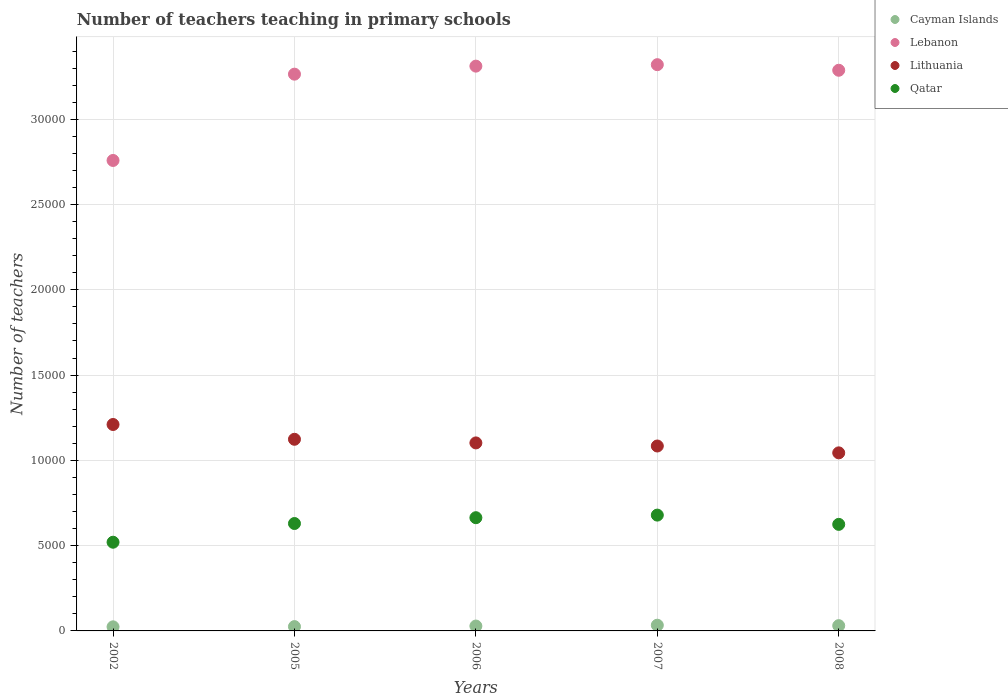Is the number of dotlines equal to the number of legend labels?
Give a very brief answer. Yes. What is the number of teachers teaching in primary schools in Lebanon in 2005?
Provide a short and direct response. 3.26e+04. Across all years, what is the maximum number of teachers teaching in primary schools in Qatar?
Your answer should be very brief. 6791. Across all years, what is the minimum number of teachers teaching in primary schools in Lebanon?
Make the answer very short. 2.76e+04. What is the total number of teachers teaching in primary schools in Qatar in the graph?
Your answer should be compact. 3.12e+04. What is the difference between the number of teachers teaching in primary schools in Lebanon in 2007 and that in 2008?
Keep it short and to the point. 327. What is the difference between the number of teachers teaching in primary schools in Lebanon in 2005 and the number of teachers teaching in primary schools in Qatar in 2007?
Make the answer very short. 2.59e+04. What is the average number of teachers teaching in primary schools in Qatar per year?
Keep it short and to the point. 6235.4. In the year 2005, what is the difference between the number of teachers teaching in primary schools in Lithuania and number of teachers teaching in primary schools in Lebanon?
Your answer should be very brief. -2.14e+04. What is the ratio of the number of teachers teaching in primary schools in Cayman Islands in 2007 to that in 2008?
Give a very brief answer. 1.08. Is the number of teachers teaching in primary schools in Lithuania in 2007 less than that in 2008?
Offer a terse response. No. What is the difference between the highest and the lowest number of teachers teaching in primary schools in Lithuania?
Your response must be concise. 1663. Is the sum of the number of teachers teaching in primary schools in Lithuania in 2006 and 2008 greater than the maximum number of teachers teaching in primary schools in Qatar across all years?
Make the answer very short. Yes. Is it the case that in every year, the sum of the number of teachers teaching in primary schools in Lebanon and number of teachers teaching in primary schools in Qatar  is greater than the number of teachers teaching in primary schools in Cayman Islands?
Ensure brevity in your answer.  Yes. How many dotlines are there?
Keep it short and to the point. 4. How many years are there in the graph?
Provide a succinct answer. 5. What is the difference between two consecutive major ticks on the Y-axis?
Offer a terse response. 5000. Does the graph contain any zero values?
Your answer should be very brief. No. Does the graph contain grids?
Give a very brief answer. Yes. Where does the legend appear in the graph?
Keep it short and to the point. Top right. What is the title of the graph?
Offer a terse response. Number of teachers teaching in primary schools. What is the label or title of the Y-axis?
Keep it short and to the point. Number of teachers. What is the Number of teachers in Cayman Islands in 2002?
Offer a terse response. 240. What is the Number of teachers in Lebanon in 2002?
Provide a short and direct response. 2.76e+04. What is the Number of teachers in Lithuania in 2002?
Your answer should be very brief. 1.21e+04. What is the Number of teachers in Qatar in 2002?
Ensure brevity in your answer.  5201. What is the Number of teachers in Cayman Islands in 2005?
Give a very brief answer. 253. What is the Number of teachers of Lebanon in 2005?
Make the answer very short. 3.26e+04. What is the Number of teachers in Lithuania in 2005?
Give a very brief answer. 1.12e+04. What is the Number of teachers of Qatar in 2005?
Provide a short and direct response. 6298. What is the Number of teachers in Cayman Islands in 2006?
Your answer should be very brief. 286. What is the Number of teachers in Lebanon in 2006?
Keep it short and to the point. 3.31e+04. What is the Number of teachers in Lithuania in 2006?
Offer a very short reply. 1.10e+04. What is the Number of teachers of Qatar in 2006?
Offer a terse response. 6639. What is the Number of teachers in Cayman Islands in 2007?
Ensure brevity in your answer.  335. What is the Number of teachers in Lebanon in 2007?
Your response must be concise. 3.32e+04. What is the Number of teachers of Lithuania in 2007?
Keep it short and to the point. 1.08e+04. What is the Number of teachers in Qatar in 2007?
Provide a succinct answer. 6791. What is the Number of teachers of Cayman Islands in 2008?
Give a very brief answer. 309. What is the Number of teachers in Lebanon in 2008?
Provide a short and direct response. 3.29e+04. What is the Number of teachers in Lithuania in 2008?
Make the answer very short. 1.04e+04. What is the Number of teachers of Qatar in 2008?
Provide a short and direct response. 6248. Across all years, what is the maximum Number of teachers of Cayman Islands?
Your answer should be compact. 335. Across all years, what is the maximum Number of teachers in Lebanon?
Make the answer very short. 3.32e+04. Across all years, what is the maximum Number of teachers in Lithuania?
Your response must be concise. 1.21e+04. Across all years, what is the maximum Number of teachers in Qatar?
Ensure brevity in your answer.  6791. Across all years, what is the minimum Number of teachers of Cayman Islands?
Give a very brief answer. 240. Across all years, what is the minimum Number of teachers of Lebanon?
Offer a terse response. 2.76e+04. Across all years, what is the minimum Number of teachers in Lithuania?
Offer a very short reply. 1.04e+04. Across all years, what is the minimum Number of teachers of Qatar?
Provide a succinct answer. 5201. What is the total Number of teachers of Cayman Islands in the graph?
Provide a succinct answer. 1423. What is the total Number of teachers in Lebanon in the graph?
Ensure brevity in your answer.  1.59e+05. What is the total Number of teachers in Lithuania in the graph?
Offer a very short reply. 5.56e+04. What is the total Number of teachers of Qatar in the graph?
Offer a terse response. 3.12e+04. What is the difference between the Number of teachers of Cayman Islands in 2002 and that in 2005?
Offer a terse response. -13. What is the difference between the Number of teachers in Lebanon in 2002 and that in 2005?
Offer a terse response. -5060. What is the difference between the Number of teachers of Lithuania in 2002 and that in 2005?
Make the answer very short. 867. What is the difference between the Number of teachers in Qatar in 2002 and that in 2005?
Offer a terse response. -1097. What is the difference between the Number of teachers of Cayman Islands in 2002 and that in 2006?
Make the answer very short. -46. What is the difference between the Number of teachers in Lebanon in 2002 and that in 2006?
Offer a very short reply. -5531. What is the difference between the Number of teachers in Lithuania in 2002 and that in 2006?
Keep it short and to the point. 1080. What is the difference between the Number of teachers of Qatar in 2002 and that in 2006?
Provide a short and direct response. -1438. What is the difference between the Number of teachers in Cayman Islands in 2002 and that in 2007?
Your answer should be compact. -95. What is the difference between the Number of teachers of Lebanon in 2002 and that in 2007?
Your answer should be very brief. -5616. What is the difference between the Number of teachers of Lithuania in 2002 and that in 2007?
Your response must be concise. 1261. What is the difference between the Number of teachers in Qatar in 2002 and that in 2007?
Keep it short and to the point. -1590. What is the difference between the Number of teachers of Cayman Islands in 2002 and that in 2008?
Keep it short and to the point. -69. What is the difference between the Number of teachers in Lebanon in 2002 and that in 2008?
Keep it short and to the point. -5289. What is the difference between the Number of teachers of Lithuania in 2002 and that in 2008?
Ensure brevity in your answer.  1663. What is the difference between the Number of teachers in Qatar in 2002 and that in 2008?
Keep it short and to the point. -1047. What is the difference between the Number of teachers in Cayman Islands in 2005 and that in 2006?
Make the answer very short. -33. What is the difference between the Number of teachers in Lebanon in 2005 and that in 2006?
Provide a short and direct response. -471. What is the difference between the Number of teachers in Lithuania in 2005 and that in 2006?
Give a very brief answer. 213. What is the difference between the Number of teachers of Qatar in 2005 and that in 2006?
Keep it short and to the point. -341. What is the difference between the Number of teachers of Cayman Islands in 2005 and that in 2007?
Your answer should be compact. -82. What is the difference between the Number of teachers of Lebanon in 2005 and that in 2007?
Offer a very short reply. -556. What is the difference between the Number of teachers of Lithuania in 2005 and that in 2007?
Provide a succinct answer. 394. What is the difference between the Number of teachers of Qatar in 2005 and that in 2007?
Your answer should be compact. -493. What is the difference between the Number of teachers of Cayman Islands in 2005 and that in 2008?
Offer a terse response. -56. What is the difference between the Number of teachers in Lebanon in 2005 and that in 2008?
Provide a short and direct response. -229. What is the difference between the Number of teachers in Lithuania in 2005 and that in 2008?
Ensure brevity in your answer.  796. What is the difference between the Number of teachers in Cayman Islands in 2006 and that in 2007?
Give a very brief answer. -49. What is the difference between the Number of teachers of Lebanon in 2006 and that in 2007?
Your answer should be very brief. -85. What is the difference between the Number of teachers of Lithuania in 2006 and that in 2007?
Provide a succinct answer. 181. What is the difference between the Number of teachers of Qatar in 2006 and that in 2007?
Provide a succinct answer. -152. What is the difference between the Number of teachers of Cayman Islands in 2006 and that in 2008?
Your answer should be compact. -23. What is the difference between the Number of teachers of Lebanon in 2006 and that in 2008?
Offer a terse response. 242. What is the difference between the Number of teachers of Lithuania in 2006 and that in 2008?
Offer a terse response. 583. What is the difference between the Number of teachers of Qatar in 2006 and that in 2008?
Your answer should be compact. 391. What is the difference between the Number of teachers in Lebanon in 2007 and that in 2008?
Ensure brevity in your answer.  327. What is the difference between the Number of teachers in Lithuania in 2007 and that in 2008?
Keep it short and to the point. 402. What is the difference between the Number of teachers in Qatar in 2007 and that in 2008?
Provide a succinct answer. 543. What is the difference between the Number of teachers in Cayman Islands in 2002 and the Number of teachers in Lebanon in 2005?
Your response must be concise. -3.24e+04. What is the difference between the Number of teachers of Cayman Islands in 2002 and the Number of teachers of Lithuania in 2005?
Keep it short and to the point. -1.10e+04. What is the difference between the Number of teachers of Cayman Islands in 2002 and the Number of teachers of Qatar in 2005?
Provide a short and direct response. -6058. What is the difference between the Number of teachers in Lebanon in 2002 and the Number of teachers in Lithuania in 2005?
Offer a very short reply. 1.63e+04. What is the difference between the Number of teachers of Lebanon in 2002 and the Number of teachers of Qatar in 2005?
Provide a short and direct response. 2.13e+04. What is the difference between the Number of teachers of Lithuania in 2002 and the Number of teachers of Qatar in 2005?
Offer a very short reply. 5806. What is the difference between the Number of teachers in Cayman Islands in 2002 and the Number of teachers in Lebanon in 2006?
Make the answer very short. -3.29e+04. What is the difference between the Number of teachers in Cayman Islands in 2002 and the Number of teachers in Lithuania in 2006?
Your answer should be compact. -1.08e+04. What is the difference between the Number of teachers of Cayman Islands in 2002 and the Number of teachers of Qatar in 2006?
Offer a terse response. -6399. What is the difference between the Number of teachers of Lebanon in 2002 and the Number of teachers of Lithuania in 2006?
Your response must be concise. 1.66e+04. What is the difference between the Number of teachers of Lebanon in 2002 and the Number of teachers of Qatar in 2006?
Keep it short and to the point. 2.09e+04. What is the difference between the Number of teachers in Lithuania in 2002 and the Number of teachers in Qatar in 2006?
Offer a terse response. 5465. What is the difference between the Number of teachers of Cayman Islands in 2002 and the Number of teachers of Lebanon in 2007?
Your answer should be very brief. -3.30e+04. What is the difference between the Number of teachers in Cayman Islands in 2002 and the Number of teachers in Lithuania in 2007?
Your answer should be compact. -1.06e+04. What is the difference between the Number of teachers of Cayman Islands in 2002 and the Number of teachers of Qatar in 2007?
Provide a succinct answer. -6551. What is the difference between the Number of teachers of Lebanon in 2002 and the Number of teachers of Lithuania in 2007?
Your answer should be very brief. 1.67e+04. What is the difference between the Number of teachers of Lebanon in 2002 and the Number of teachers of Qatar in 2007?
Your answer should be compact. 2.08e+04. What is the difference between the Number of teachers of Lithuania in 2002 and the Number of teachers of Qatar in 2007?
Your response must be concise. 5313. What is the difference between the Number of teachers in Cayman Islands in 2002 and the Number of teachers in Lebanon in 2008?
Make the answer very short. -3.26e+04. What is the difference between the Number of teachers of Cayman Islands in 2002 and the Number of teachers of Lithuania in 2008?
Offer a terse response. -1.02e+04. What is the difference between the Number of teachers of Cayman Islands in 2002 and the Number of teachers of Qatar in 2008?
Offer a very short reply. -6008. What is the difference between the Number of teachers in Lebanon in 2002 and the Number of teachers in Lithuania in 2008?
Your answer should be compact. 1.71e+04. What is the difference between the Number of teachers of Lebanon in 2002 and the Number of teachers of Qatar in 2008?
Make the answer very short. 2.13e+04. What is the difference between the Number of teachers in Lithuania in 2002 and the Number of teachers in Qatar in 2008?
Offer a very short reply. 5856. What is the difference between the Number of teachers of Cayman Islands in 2005 and the Number of teachers of Lebanon in 2006?
Your answer should be compact. -3.29e+04. What is the difference between the Number of teachers in Cayman Islands in 2005 and the Number of teachers in Lithuania in 2006?
Make the answer very short. -1.08e+04. What is the difference between the Number of teachers in Cayman Islands in 2005 and the Number of teachers in Qatar in 2006?
Your answer should be very brief. -6386. What is the difference between the Number of teachers of Lebanon in 2005 and the Number of teachers of Lithuania in 2006?
Make the answer very short. 2.16e+04. What is the difference between the Number of teachers in Lebanon in 2005 and the Number of teachers in Qatar in 2006?
Your response must be concise. 2.60e+04. What is the difference between the Number of teachers of Lithuania in 2005 and the Number of teachers of Qatar in 2006?
Ensure brevity in your answer.  4598. What is the difference between the Number of teachers in Cayman Islands in 2005 and the Number of teachers in Lebanon in 2007?
Offer a very short reply. -3.29e+04. What is the difference between the Number of teachers in Cayman Islands in 2005 and the Number of teachers in Lithuania in 2007?
Give a very brief answer. -1.06e+04. What is the difference between the Number of teachers in Cayman Islands in 2005 and the Number of teachers in Qatar in 2007?
Your answer should be very brief. -6538. What is the difference between the Number of teachers of Lebanon in 2005 and the Number of teachers of Lithuania in 2007?
Give a very brief answer. 2.18e+04. What is the difference between the Number of teachers in Lebanon in 2005 and the Number of teachers in Qatar in 2007?
Provide a succinct answer. 2.59e+04. What is the difference between the Number of teachers of Lithuania in 2005 and the Number of teachers of Qatar in 2007?
Make the answer very short. 4446. What is the difference between the Number of teachers of Cayman Islands in 2005 and the Number of teachers of Lebanon in 2008?
Keep it short and to the point. -3.26e+04. What is the difference between the Number of teachers of Cayman Islands in 2005 and the Number of teachers of Lithuania in 2008?
Give a very brief answer. -1.02e+04. What is the difference between the Number of teachers in Cayman Islands in 2005 and the Number of teachers in Qatar in 2008?
Your answer should be very brief. -5995. What is the difference between the Number of teachers in Lebanon in 2005 and the Number of teachers in Lithuania in 2008?
Provide a succinct answer. 2.22e+04. What is the difference between the Number of teachers in Lebanon in 2005 and the Number of teachers in Qatar in 2008?
Offer a terse response. 2.64e+04. What is the difference between the Number of teachers in Lithuania in 2005 and the Number of teachers in Qatar in 2008?
Make the answer very short. 4989. What is the difference between the Number of teachers in Cayman Islands in 2006 and the Number of teachers in Lebanon in 2007?
Make the answer very short. -3.29e+04. What is the difference between the Number of teachers in Cayman Islands in 2006 and the Number of teachers in Lithuania in 2007?
Your answer should be compact. -1.06e+04. What is the difference between the Number of teachers in Cayman Islands in 2006 and the Number of teachers in Qatar in 2007?
Provide a succinct answer. -6505. What is the difference between the Number of teachers in Lebanon in 2006 and the Number of teachers in Lithuania in 2007?
Offer a very short reply. 2.23e+04. What is the difference between the Number of teachers of Lebanon in 2006 and the Number of teachers of Qatar in 2007?
Offer a very short reply. 2.63e+04. What is the difference between the Number of teachers of Lithuania in 2006 and the Number of teachers of Qatar in 2007?
Offer a very short reply. 4233. What is the difference between the Number of teachers of Cayman Islands in 2006 and the Number of teachers of Lebanon in 2008?
Provide a short and direct response. -3.26e+04. What is the difference between the Number of teachers of Cayman Islands in 2006 and the Number of teachers of Lithuania in 2008?
Provide a short and direct response. -1.02e+04. What is the difference between the Number of teachers of Cayman Islands in 2006 and the Number of teachers of Qatar in 2008?
Your response must be concise. -5962. What is the difference between the Number of teachers of Lebanon in 2006 and the Number of teachers of Lithuania in 2008?
Provide a succinct answer. 2.27e+04. What is the difference between the Number of teachers of Lebanon in 2006 and the Number of teachers of Qatar in 2008?
Offer a terse response. 2.69e+04. What is the difference between the Number of teachers in Lithuania in 2006 and the Number of teachers in Qatar in 2008?
Make the answer very short. 4776. What is the difference between the Number of teachers in Cayman Islands in 2007 and the Number of teachers in Lebanon in 2008?
Your answer should be very brief. -3.25e+04. What is the difference between the Number of teachers of Cayman Islands in 2007 and the Number of teachers of Lithuania in 2008?
Your answer should be compact. -1.01e+04. What is the difference between the Number of teachers of Cayman Islands in 2007 and the Number of teachers of Qatar in 2008?
Ensure brevity in your answer.  -5913. What is the difference between the Number of teachers of Lebanon in 2007 and the Number of teachers of Lithuania in 2008?
Offer a very short reply. 2.28e+04. What is the difference between the Number of teachers of Lebanon in 2007 and the Number of teachers of Qatar in 2008?
Keep it short and to the point. 2.70e+04. What is the difference between the Number of teachers of Lithuania in 2007 and the Number of teachers of Qatar in 2008?
Provide a succinct answer. 4595. What is the average Number of teachers in Cayman Islands per year?
Your response must be concise. 284.6. What is the average Number of teachers of Lebanon per year?
Make the answer very short. 3.19e+04. What is the average Number of teachers of Lithuania per year?
Your answer should be compact. 1.11e+04. What is the average Number of teachers in Qatar per year?
Keep it short and to the point. 6235.4. In the year 2002, what is the difference between the Number of teachers of Cayman Islands and Number of teachers of Lebanon?
Ensure brevity in your answer.  -2.73e+04. In the year 2002, what is the difference between the Number of teachers of Cayman Islands and Number of teachers of Lithuania?
Provide a short and direct response. -1.19e+04. In the year 2002, what is the difference between the Number of teachers in Cayman Islands and Number of teachers in Qatar?
Give a very brief answer. -4961. In the year 2002, what is the difference between the Number of teachers of Lebanon and Number of teachers of Lithuania?
Provide a succinct answer. 1.55e+04. In the year 2002, what is the difference between the Number of teachers of Lebanon and Number of teachers of Qatar?
Your answer should be compact. 2.24e+04. In the year 2002, what is the difference between the Number of teachers of Lithuania and Number of teachers of Qatar?
Keep it short and to the point. 6903. In the year 2005, what is the difference between the Number of teachers in Cayman Islands and Number of teachers in Lebanon?
Your answer should be compact. -3.24e+04. In the year 2005, what is the difference between the Number of teachers in Cayman Islands and Number of teachers in Lithuania?
Offer a very short reply. -1.10e+04. In the year 2005, what is the difference between the Number of teachers in Cayman Islands and Number of teachers in Qatar?
Make the answer very short. -6045. In the year 2005, what is the difference between the Number of teachers of Lebanon and Number of teachers of Lithuania?
Your response must be concise. 2.14e+04. In the year 2005, what is the difference between the Number of teachers of Lebanon and Number of teachers of Qatar?
Offer a very short reply. 2.63e+04. In the year 2005, what is the difference between the Number of teachers of Lithuania and Number of teachers of Qatar?
Offer a very short reply. 4939. In the year 2006, what is the difference between the Number of teachers of Cayman Islands and Number of teachers of Lebanon?
Provide a succinct answer. -3.28e+04. In the year 2006, what is the difference between the Number of teachers of Cayman Islands and Number of teachers of Lithuania?
Your response must be concise. -1.07e+04. In the year 2006, what is the difference between the Number of teachers of Cayman Islands and Number of teachers of Qatar?
Make the answer very short. -6353. In the year 2006, what is the difference between the Number of teachers of Lebanon and Number of teachers of Lithuania?
Offer a terse response. 2.21e+04. In the year 2006, what is the difference between the Number of teachers of Lebanon and Number of teachers of Qatar?
Make the answer very short. 2.65e+04. In the year 2006, what is the difference between the Number of teachers of Lithuania and Number of teachers of Qatar?
Provide a succinct answer. 4385. In the year 2007, what is the difference between the Number of teachers in Cayman Islands and Number of teachers in Lebanon?
Your response must be concise. -3.29e+04. In the year 2007, what is the difference between the Number of teachers of Cayman Islands and Number of teachers of Lithuania?
Make the answer very short. -1.05e+04. In the year 2007, what is the difference between the Number of teachers of Cayman Islands and Number of teachers of Qatar?
Give a very brief answer. -6456. In the year 2007, what is the difference between the Number of teachers of Lebanon and Number of teachers of Lithuania?
Offer a terse response. 2.24e+04. In the year 2007, what is the difference between the Number of teachers in Lebanon and Number of teachers in Qatar?
Offer a terse response. 2.64e+04. In the year 2007, what is the difference between the Number of teachers of Lithuania and Number of teachers of Qatar?
Offer a very short reply. 4052. In the year 2008, what is the difference between the Number of teachers of Cayman Islands and Number of teachers of Lebanon?
Your response must be concise. -3.26e+04. In the year 2008, what is the difference between the Number of teachers of Cayman Islands and Number of teachers of Lithuania?
Make the answer very short. -1.01e+04. In the year 2008, what is the difference between the Number of teachers of Cayman Islands and Number of teachers of Qatar?
Offer a terse response. -5939. In the year 2008, what is the difference between the Number of teachers of Lebanon and Number of teachers of Lithuania?
Make the answer very short. 2.24e+04. In the year 2008, what is the difference between the Number of teachers in Lebanon and Number of teachers in Qatar?
Your answer should be very brief. 2.66e+04. In the year 2008, what is the difference between the Number of teachers in Lithuania and Number of teachers in Qatar?
Offer a very short reply. 4193. What is the ratio of the Number of teachers of Cayman Islands in 2002 to that in 2005?
Your answer should be compact. 0.95. What is the ratio of the Number of teachers of Lebanon in 2002 to that in 2005?
Provide a short and direct response. 0.84. What is the ratio of the Number of teachers of Lithuania in 2002 to that in 2005?
Offer a very short reply. 1.08. What is the ratio of the Number of teachers of Qatar in 2002 to that in 2005?
Make the answer very short. 0.83. What is the ratio of the Number of teachers in Cayman Islands in 2002 to that in 2006?
Give a very brief answer. 0.84. What is the ratio of the Number of teachers in Lebanon in 2002 to that in 2006?
Your answer should be very brief. 0.83. What is the ratio of the Number of teachers of Lithuania in 2002 to that in 2006?
Offer a very short reply. 1.1. What is the ratio of the Number of teachers of Qatar in 2002 to that in 2006?
Give a very brief answer. 0.78. What is the ratio of the Number of teachers in Cayman Islands in 2002 to that in 2007?
Offer a terse response. 0.72. What is the ratio of the Number of teachers of Lebanon in 2002 to that in 2007?
Your response must be concise. 0.83. What is the ratio of the Number of teachers of Lithuania in 2002 to that in 2007?
Offer a very short reply. 1.12. What is the ratio of the Number of teachers in Qatar in 2002 to that in 2007?
Give a very brief answer. 0.77. What is the ratio of the Number of teachers of Cayman Islands in 2002 to that in 2008?
Your answer should be very brief. 0.78. What is the ratio of the Number of teachers in Lebanon in 2002 to that in 2008?
Offer a very short reply. 0.84. What is the ratio of the Number of teachers of Lithuania in 2002 to that in 2008?
Your answer should be very brief. 1.16. What is the ratio of the Number of teachers of Qatar in 2002 to that in 2008?
Make the answer very short. 0.83. What is the ratio of the Number of teachers in Cayman Islands in 2005 to that in 2006?
Ensure brevity in your answer.  0.88. What is the ratio of the Number of teachers in Lebanon in 2005 to that in 2006?
Your response must be concise. 0.99. What is the ratio of the Number of teachers in Lithuania in 2005 to that in 2006?
Provide a succinct answer. 1.02. What is the ratio of the Number of teachers in Qatar in 2005 to that in 2006?
Your answer should be compact. 0.95. What is the ratio of the Number of teachers in Cayman Islands in 2005 to that in 2007?
Offer a terse response. 0.76. What is the ratio of the Number of teachers in Lebanon in 2005 to that in 2007?
Give a very brief answer. 0.98. What is the ratio of the Number of teachers in Lithuania in 2005 to that in 2007?
Offer a very short reply. 1.04. What is the ratio of the Number of teachers in Qatar in 2005 to that in 2007?
Provide a succinct answer. 0.93. What is the ratio of the Number of teachers of Cayman Islands in 2005 to that in 2008?
Provide a short and direct response. 0.82. What is the ratio of the Number of teachers in Lebanon in 2005 to that in 2008?
Give a very brief answer. 0.99. What is the ratio of the Number of teachers in Lithuania in 2005 to that in 2008?
Your answer should be very brief. 1.08. What is the ratio of the Number of teachers in Qatar in 2005 to that in 2008?
Offer a terse response. 1.01. What is the ratio of the Number of teachers of Cayman Islands in 2006 to that in 2007?
Make the answer very short. 0.85. What is the ratio of the Number of teachers of Lebanon in 2006 to that in 2007?
Your answer should be compact. 1. What is the ratio of the Number of teachers of Lithuania in 2006 to that in 2007?
Provide a short and direct response. 1.02. What is the ratio of the Number of teachers of Qatar in 2006 to that in 2007?
Keep it short and to the point. 0.98. What is the ratio of the Number of teachers in Cayman Islands in 2006 to that in 2008?
Your answer should be very brief. 0.93. What is the ratio of the Number of teachers of Lebanon in 2006 to that in 2008?
Offer a terse response. 1.01. What is the ratio of the Number of teachers in Lithuania in 2006 to that in 2008?
Offer a terse response. 1.06. What is the ratio of the Number of teachers of Qatar in 2006 to that in 2008?
Offer a terse response. 1.06. What is the ratio of the Number of teachers in Cayman Islands in 2007 to that in 2008?
Ensure brevity in your answer.  1.08. What is the ratio of the Number of teachers in Lebanon in 2007 to that in 2008?
Your response must be concise. 1.01. What is the ratio of the Number of teachers in Lithuania in 2007 to that in 2008?
Your answer should be compact. 1.04. What is the ratio of the Number of teachers of Qatar in 2007 to that in 2008?
Provide a succinct answer. 1.09. What is the difference between the highest and the second highest Number of teachers in Lithuania?
Give a very brief answer. 867. What is the difference between the highest and the second highest Number of teachers in Qatar?
Offer a terse response. 152. What is the difference between the highest and the lowest Number of teachers of Lebanon?
Provide a succinct answer. 5616. What is the difference between the highest and the lowest Number of teachers of Lithuania?
Ensure brevity in your answer.  1663. What is the difference between the highest and the lowest Number of teachers of Qatar?
Offer a terse response. 1590. 